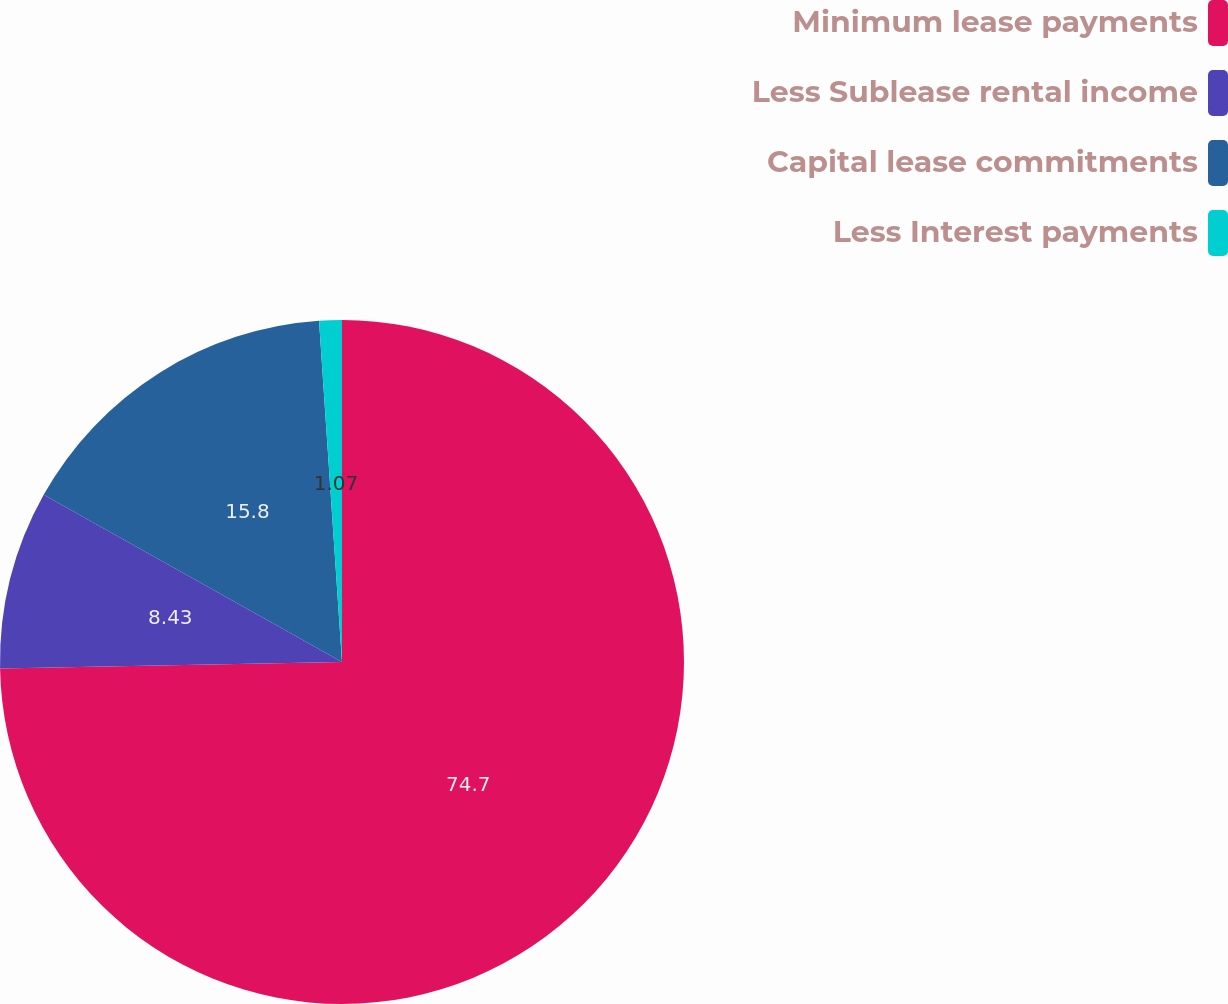<chart> <loc_0><loc_0><loc_500><loc_500><pie_chart><fcel>Minimum lease payments<fcel>Less Sublease rental income<fcel>Capital lease commitments<fcel>Less Interest payments<nl><fcel>74.7%<fcel>8.43%<fcel>15.8%<fcel>1.07%<nl></chart> 